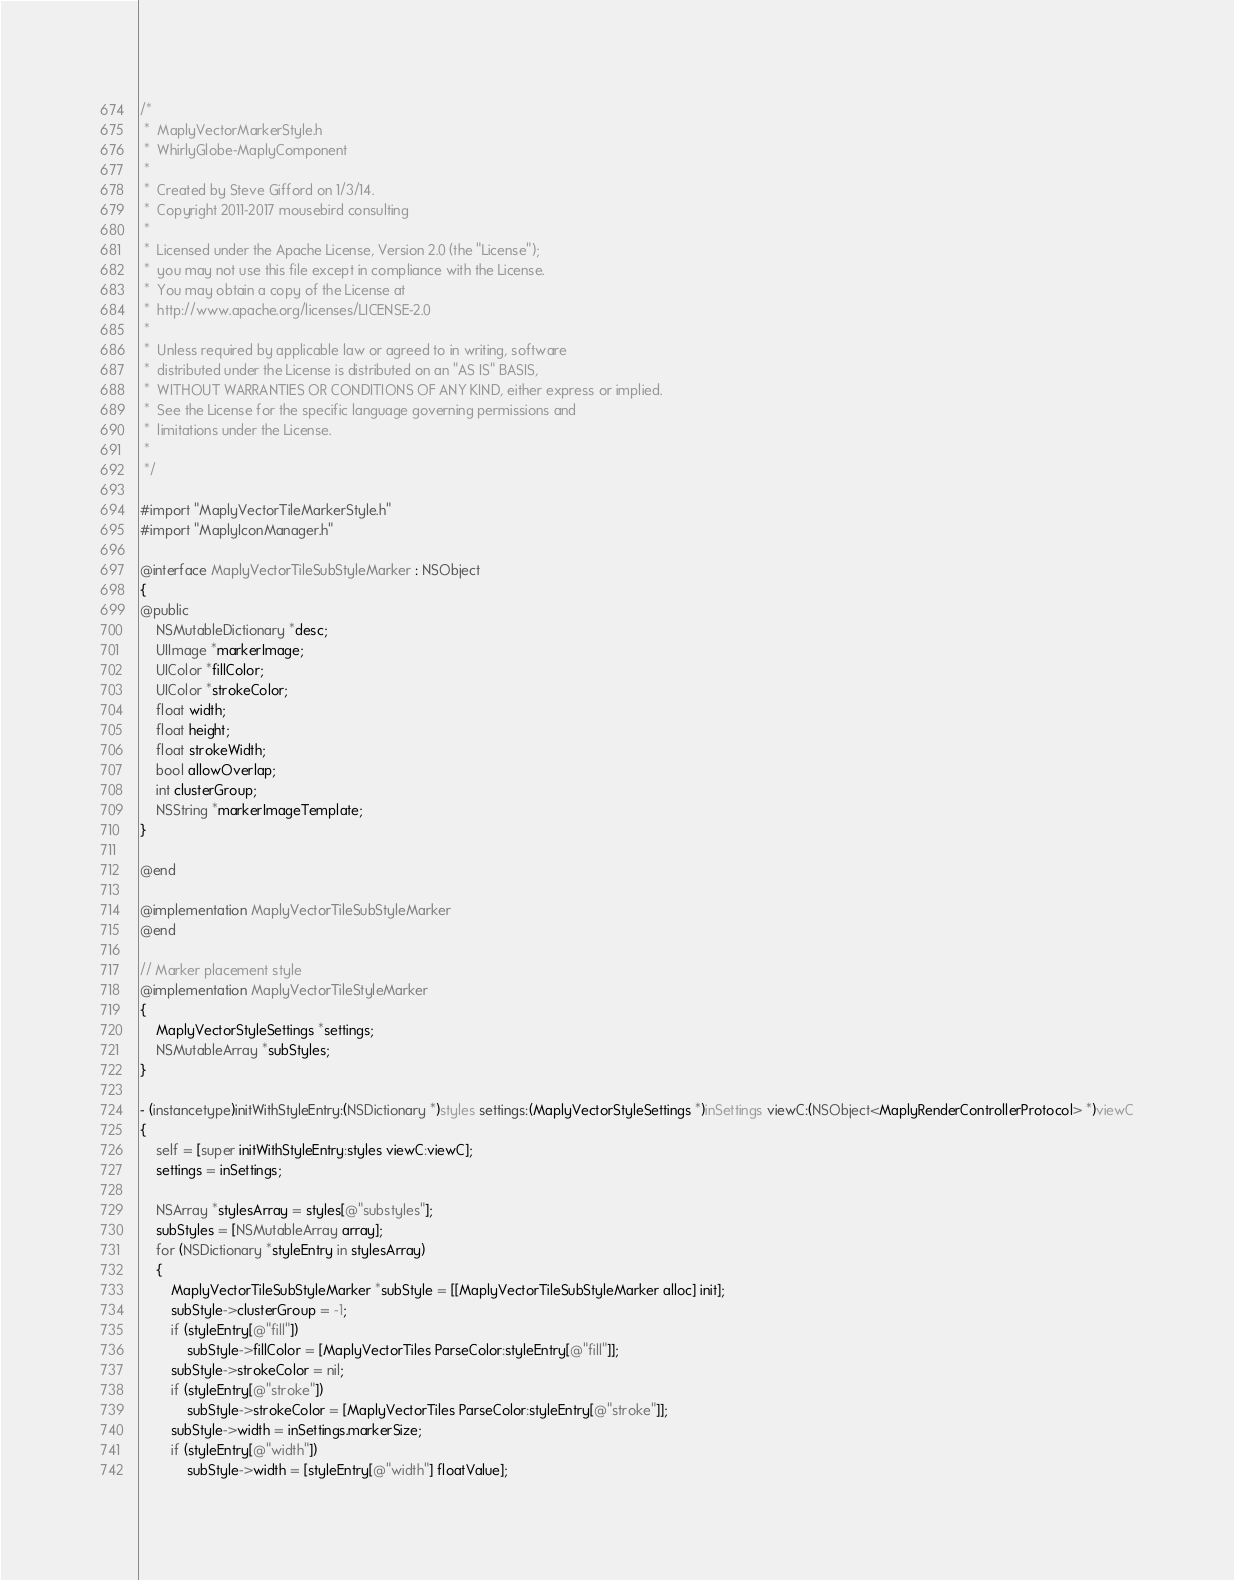<code> <loc_0><loc_0><loc_500><loc_500><_ObjectiveC_>/*
 *  MaplyVectorMarkerStyle.h
 *  WhirlyGlobe-MaplyComponent
 *
 *  Created by Steve Gifford on 1/3/14.
 *  Copyright 2011-2017 mousebird consulting
 *
 *  Licensed under the Apache License, Version 2.0 (the "License");
 *  you may not use this file except in compliance with the License.
 *  You may obtain a copy of the License at
 *  http://www.apache.org/licenses/LICENSE-2.0
 *
 *  Unless required by applicable law or agreed to in writing, software
 *  distributed under the License is distributed on an "AS IS" BASIS,
 *  WITHOUT WARRANTIES OR CONDITIONS OF ANY KIND, either express or implied.
 *  See the License for the specific language governing permissions and
 *  limitations under the License.
 *
 */

#import "MaplyVectorTileMarkerStyle.h"
#import "MaplyIconManager.h"

@interface MaplyVectorTileSubStyleMarker : NSObject
{
@public
    NSMutableDictionary *desc;
    UIImage *markerImage;
    UIColor *fillColor;
    UIColor *strokeColor;
    float width;
    float height;
    float strokeWidth;
    bool allowOverlap;
    int clusterGroup;
    NSString *markerImageTemplate;
}

@end

@implementation MaplyVectorTileSubStyleMarker
@end

// Marker placement style
@implementation MaplyVectorTileStyleMarker
{
    MaplyVectorStyleSettings *settings;
    NSMutableArray *subStyles;
}

- (instancetype)initWithStyleEntry:(NSDictionary *)styles settings:(MaplyVectorStyleSettings *)inSettings viewC:(NSObject<MaplyRenderControllerProtocol> *)viewC
{
    self = [super initWithStyleEntry:styles viewC:viewC];
    settings = inSettings;
    
    NSArray *stylesArray = styles[@"substyles"];
    subStyles = [NSMutableArray array];
    for (NSDictionary *styleEntry in stylesArray)
    {
        MaplyVectorTileSubStyleMarker *subStyle = [[MaplyVectorTileSubStyleMarker alloc] init];
        subStyle->clusterGroup = -1;
        if (styleEntry[@"fill"])
            subStyle->fillColor = [MaplyVectorTiles ParseColor:styleEntry[@"fill"]];
        subStyle->strokeColor = nil;
        if (styleEntry[@"stroke"])
            subStyle->strokeColor = [MaplyVectorTiles ParseColor:styleEntry[@"stroke"]];
        subStyle->width = inSettings.markerSize;
        if (styleEntry[@"width"])
            subStyle->width = [styleEntry[@"width"] floatValue];</code> 